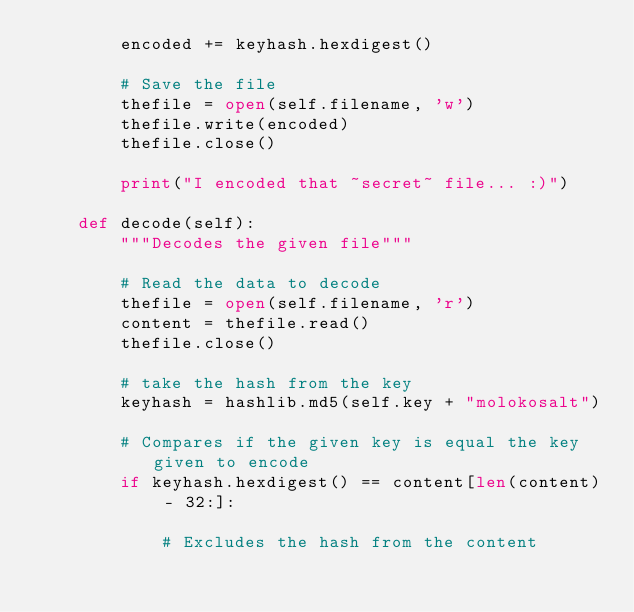Convert code to text. <code><loc_0><loc_0><loc_500><loc_500><_Python_>        encoded += keyhash.hexdigest()

        # Save the file
        thefile = open(self.filename, 'w')
        thefile.write(encoded)
        thefile.close()

        print("I encoded that ~secret~ file... :)")

    def decode(self):
        """Decodes the given file"""

        # Read the data to decode
        thefile = open(self.filename, 'r')
        content = thefile.read()
        thefile.close()

        # take the hash from the key
        keyhash = hashlib.md5(self.key + "molokosalt")

        # Compares if the given key is equal the key given to encode
        if keyhash.hexdigest() == content[len(content) - 32:]:

            # Excludes the hash from the content</code> 